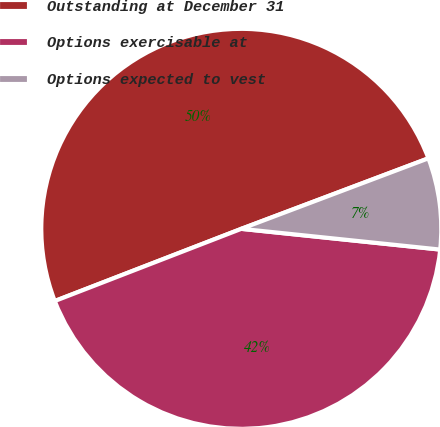<chart> <loc_0><loc_0><loc_500><loc_500><pie_chart><fcel>Outstanding at December 31<fcel>Options exercisable at<fcel>Options expected to vest<nl><fcel>50.14%<fcel>42.47%<fcel>7.39%<nl></chart> 